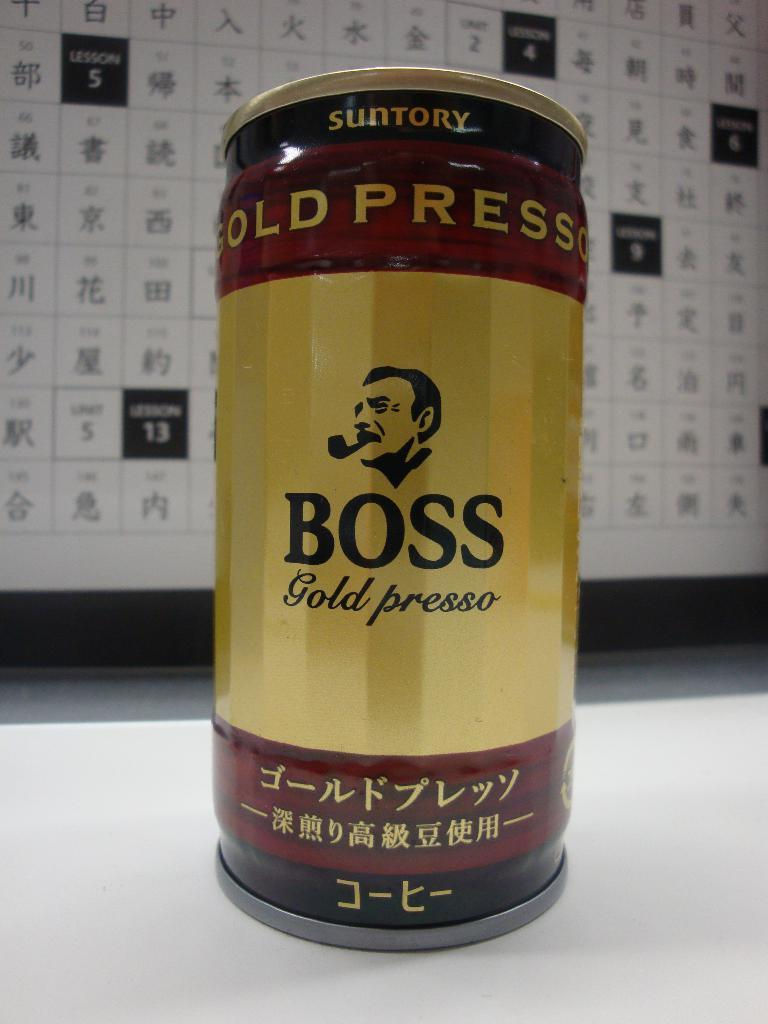<image>
Give a short and clear explanation of the subsequent image. a can of boss gold presso that says suntory at the top of it 